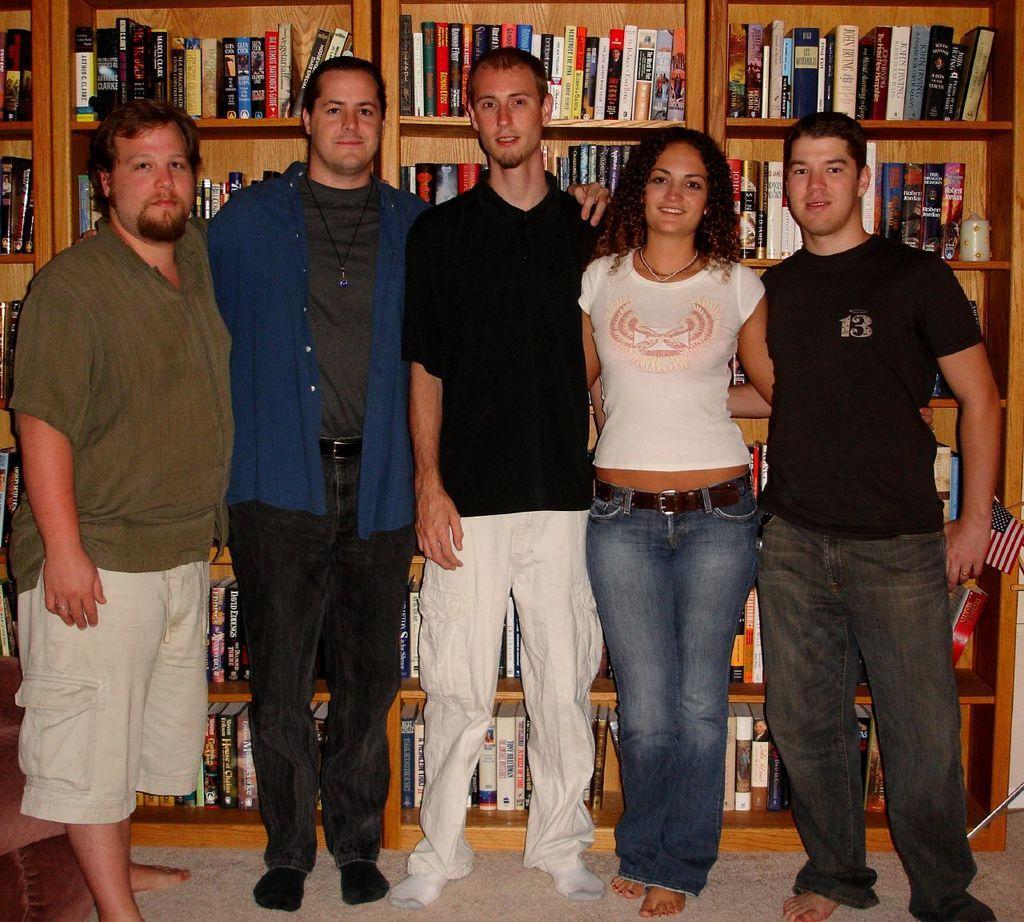Could you give a brief overview of what you see in this image? In the image I can see four men and a lady who are standing and behind there are some shelves in which some books books are arranged. 